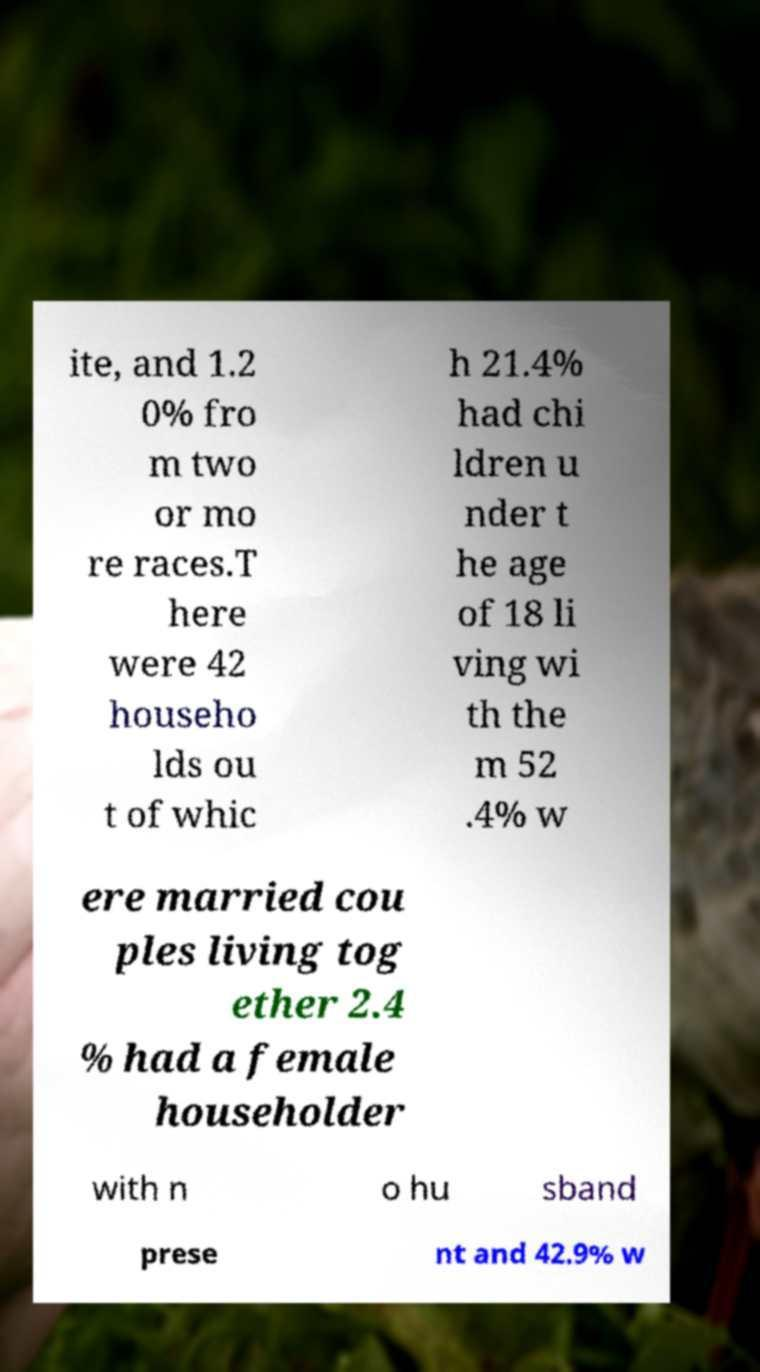Can you read and provide the text displayed in the image?This photo seems to have some interesting text. Can you extract and type it out for me? ite, and 1.2 0% fro m two or mo re races.T here were 42 househo lds ou t of whic h 21.4% had chi ldren u nder t he age of 18 li ving wi th the m 52 .4% w ere married cou ples living tog ether 2.4 % had a female householder with n o hu sband prese nt and 42.9% w 